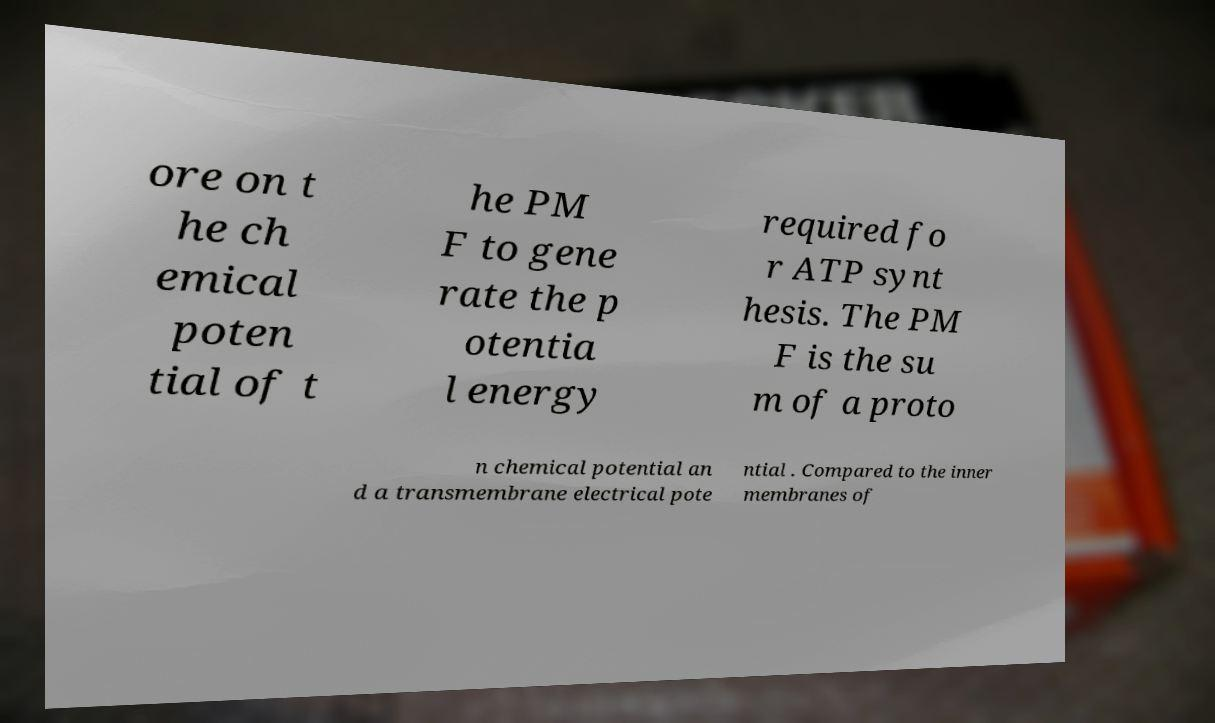Can you accurately transcribe the text from the provided image for me? ore on t he ch emical poten tial of t he PM F to gene rate the p otentia l energy required fo r ATP synt hesis. The PM F is the su m of a proto n chemical potential an d a transmembrane electrical pote ntial . Compared to the inner membranes of 